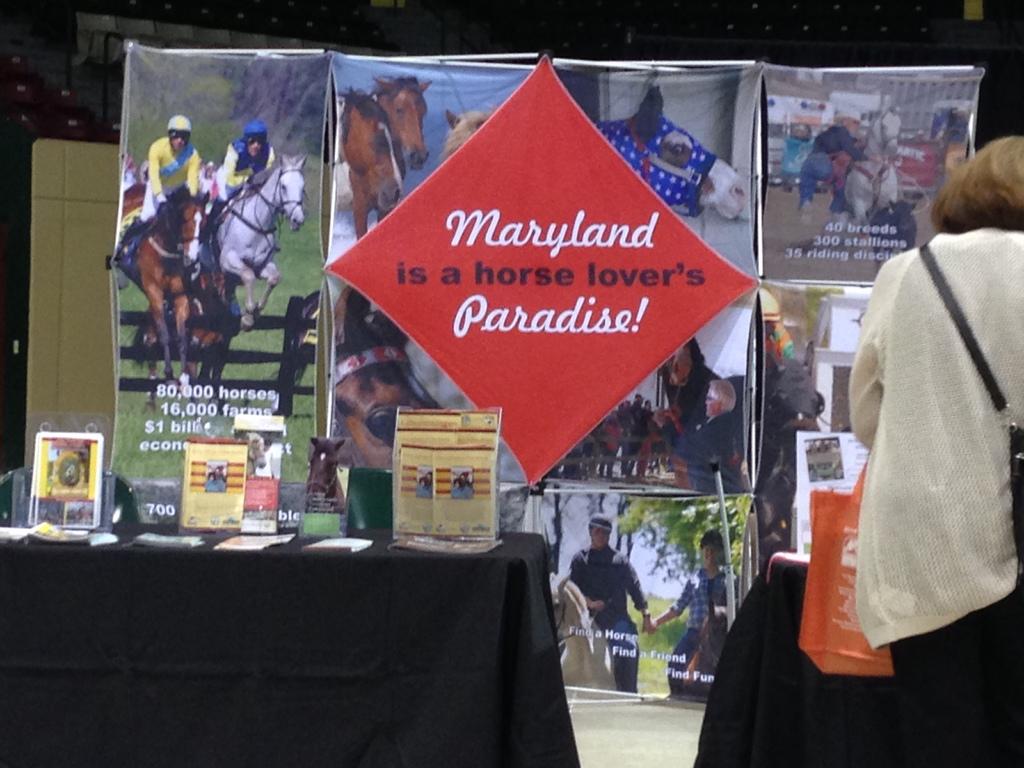How many breeds in the photo on the top right?
Your response must be concise. 40. 